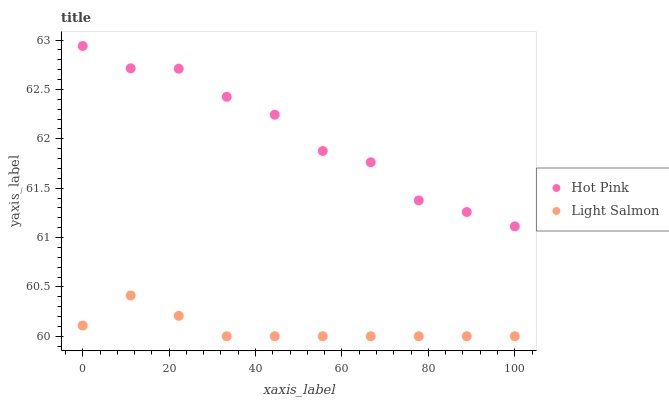Does Light Salmon have the minimum area under the curve?
Answer yes or no. Yes. Does Hot Pink have the maximum area under the curve?
Answer yes or no. Yes. Does Hot Pink have the minimum area under the curve?
Answer yes or no. No. Is Light Salmon the smoothest?
Answer yes or no. Yes. Is Hot Pink the roughest?
Answer yes or no. Yes. Is Hot Pink the smoothest?
Answer yes or no. No. Does Light Salmon have the lowest value?
Answer yes or no. Yes. Does Hot Pink have the lowest value?
Answer yes or no. No. Does Hot Pink have the highest value?
Answer yes or no. Yes. Is Light Salmon less than Hot Pink?
Answer yes or no. Yes. Is Hot Pink greater than Light Salmon?
Answer yes or no. Yes. Does Light Salmon intersect Hot Pink?
Answer yes or no. No. 